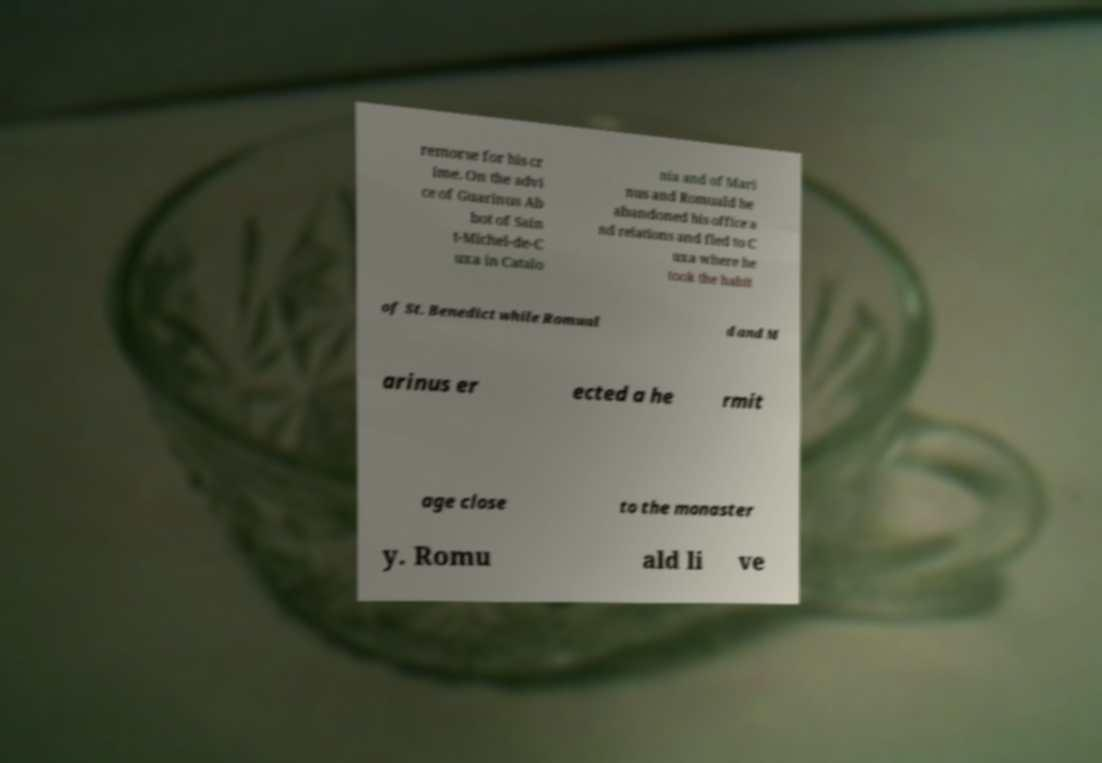Could you extract and type out the text from this image? remorse for his cr ime. On the advi ce of Guarinus Ab bot of Sain t-Michel-de-C uxa in Catalo nia and of Mari nus and Romuald he abandoned his office a nd relations and fled to C uxa where he took the habit of St. Benedict while Romual d and M arinus er ected a he rmit age close to the monaster y. Romu ald li ve 